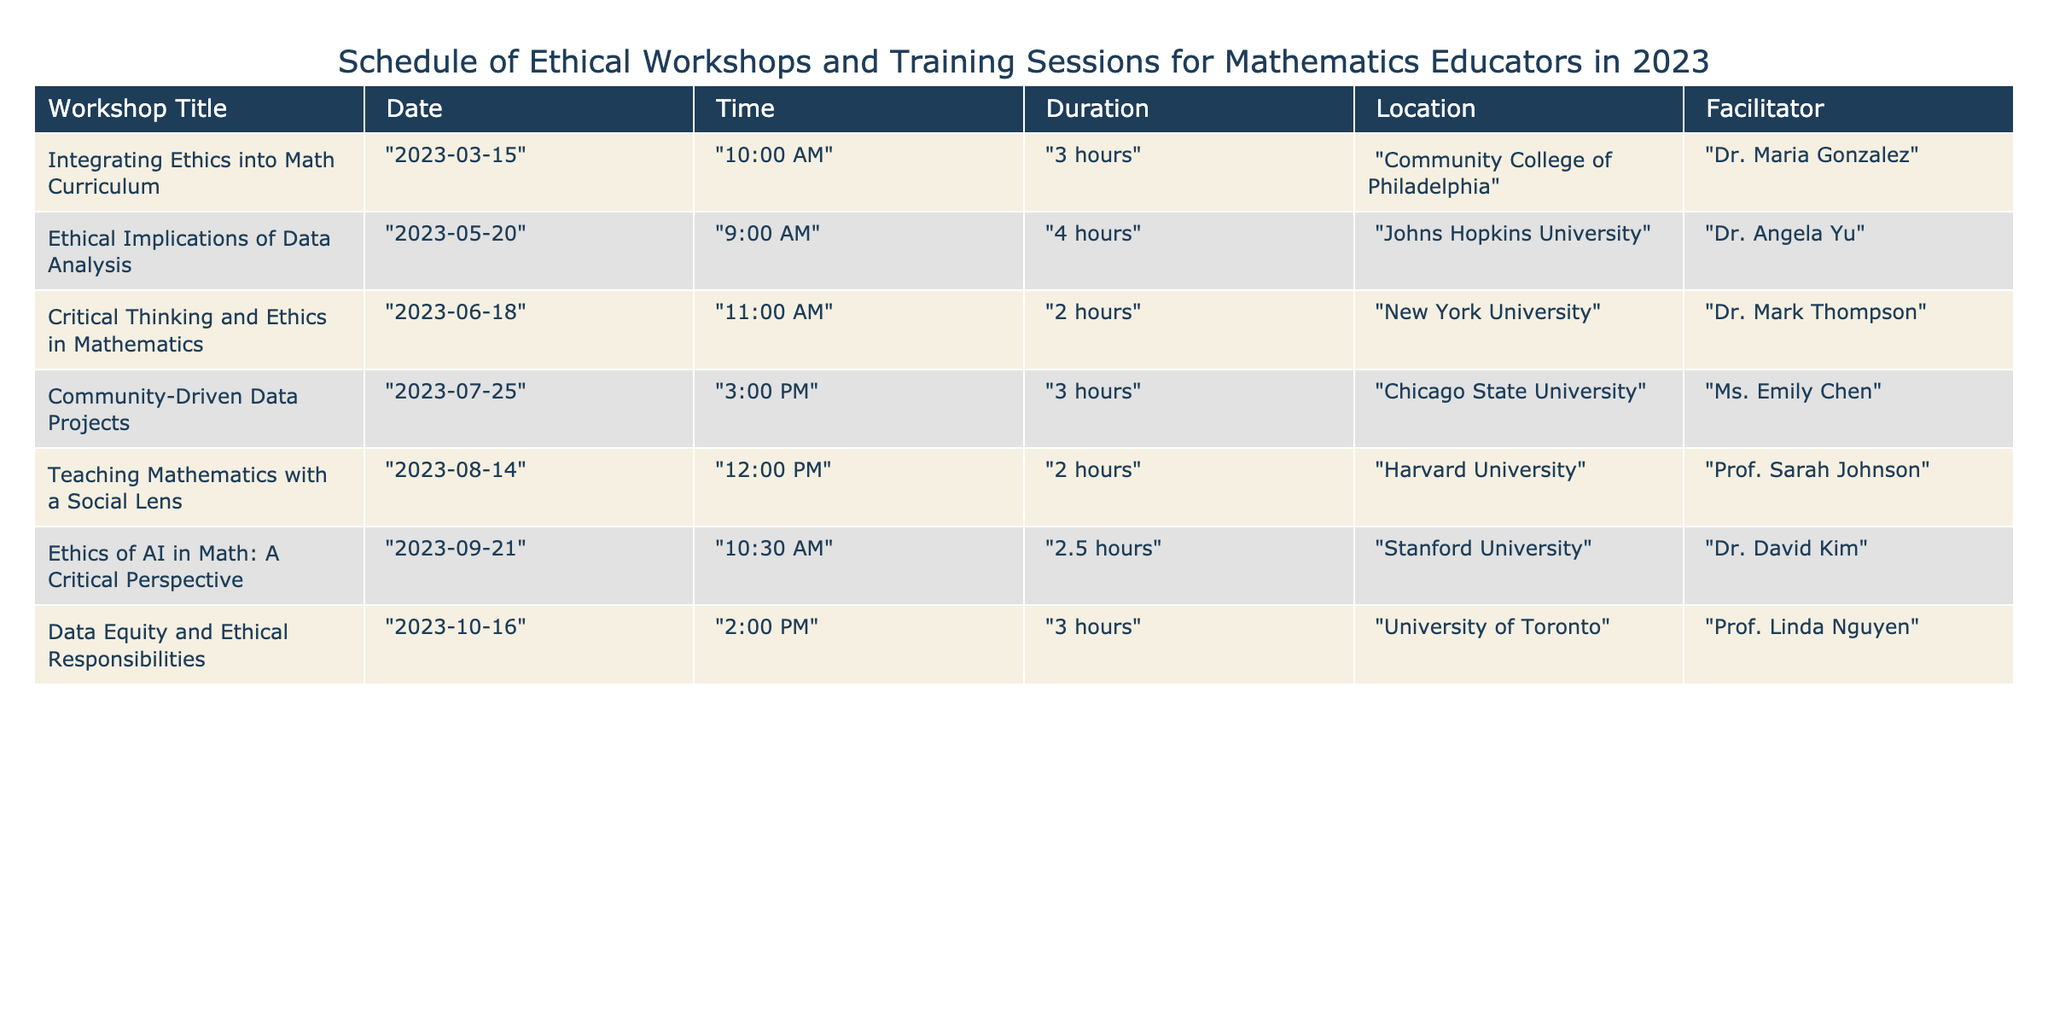What is the title of the workshop scheduled for May 20, 2023? The table lists the workshop titles along with their corresponding dates. For May 20, 2023, the workshop titled "Ethical Implications of Data Analysis" is mentioned.
Answer: "Ethical Implications of Data Analysis" Which workshop has the longest duration? To find the longest duration, we look at the "Duration" column for all workshops: 3 hours, 4 hours, 2 hours, 3 hours, 2 hours, 2.5 hours, and 3 hours. The longest is 4 hours for the workshop on May 20, 2023.
Answer: 4 hours Is the workshop "Teaching Mathematics with a Social Lens" held at Harvard University? The table provides a specific location for each workshop. The "Teaching Mathematics with a Social Lens" workshop is indeed listed with Harvard University as its location.
Answer: Yes What is the average duration of the workshops? First, we convert the durations to hours: 3, 4, 2, 3, 2, 2.5, 3. The total duration is 3 + 4 + 2 + 3 + 2 + 2.5 + 3 = 20.5 hours. There are 7 workshops, so the average is 20.5 / 7 ≈ 2.93 hours.
Answer: Approximately 2.93 hours Which facilitator is hosting the workshop titled "Community-Driven Data Projects"? By examining the table, we can identify the facilitator for the "Community-Driven Data Projects" workshop. It is listed as Ms. Emily Chen.
Answer: Ms. Emily Chen How many workshops are scheduled in the month of August? We review the table to find workshops scheduled in August. Only one workshop, titled "Teaching Mathematics with a Social Lens," is listed for August 14, 2023.
Answer: 1 What time does the workshop "Ethics of AI in Math: A Critical Perspective" start? The start time for this workshop is provided in the table. It is listed as 10:30 AM on September 21, 2023.
Answer: 10:30 AM How many workshops are facilitated by professors? We scan the "Facilitator" column to count the titles "Prof." indicating they are professors. Two workshops are facilitated by professors: "Teaching Mathematics with a Social Lens" and "Data Equity and Ethical Responsibilities." Thus, there are two such workshops.
Answer: 2 Which workshop is scheduled last in terms of date? The workshops are compared based on their dates. The last date listed is October 16, 2023, for the workshop "Data Equity and Ethical Responsibilities."
Answer: "Data Equity and Ethical Responsibilities" 